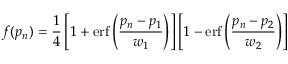Convert formula to latex. <formula><loc_0><loc_0><loc_500><loc_500>f ( p _ { n } ) = \frac { 1 } { 4 } \left [ 1 + e r f \left ( \frac { p _ { n } - p _ { 1 } } { w _ { 1 } } \right ) \right ] \left [ 1 - e r f \left ( \frac { p _ { n } - p _ { 2 } } { w _ { 2 } } \right ) \right ]</formula> 